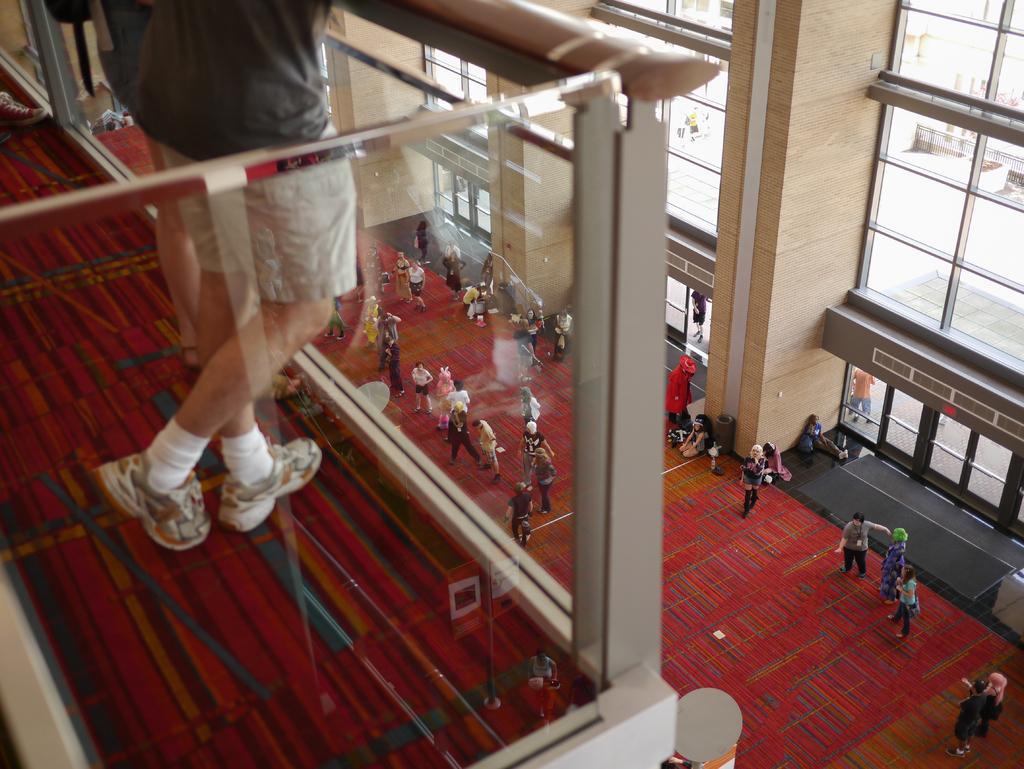Could you give a brief overview of what you see in this image? In this picture we can see glass railing and a person is standing wearing shoes. At the bottom portion of the picture we can see a floor carpet on the floor and we can see people. On the right side of the picture we can see window glasses and walls. Through glass outside view is visible and we can see people. 